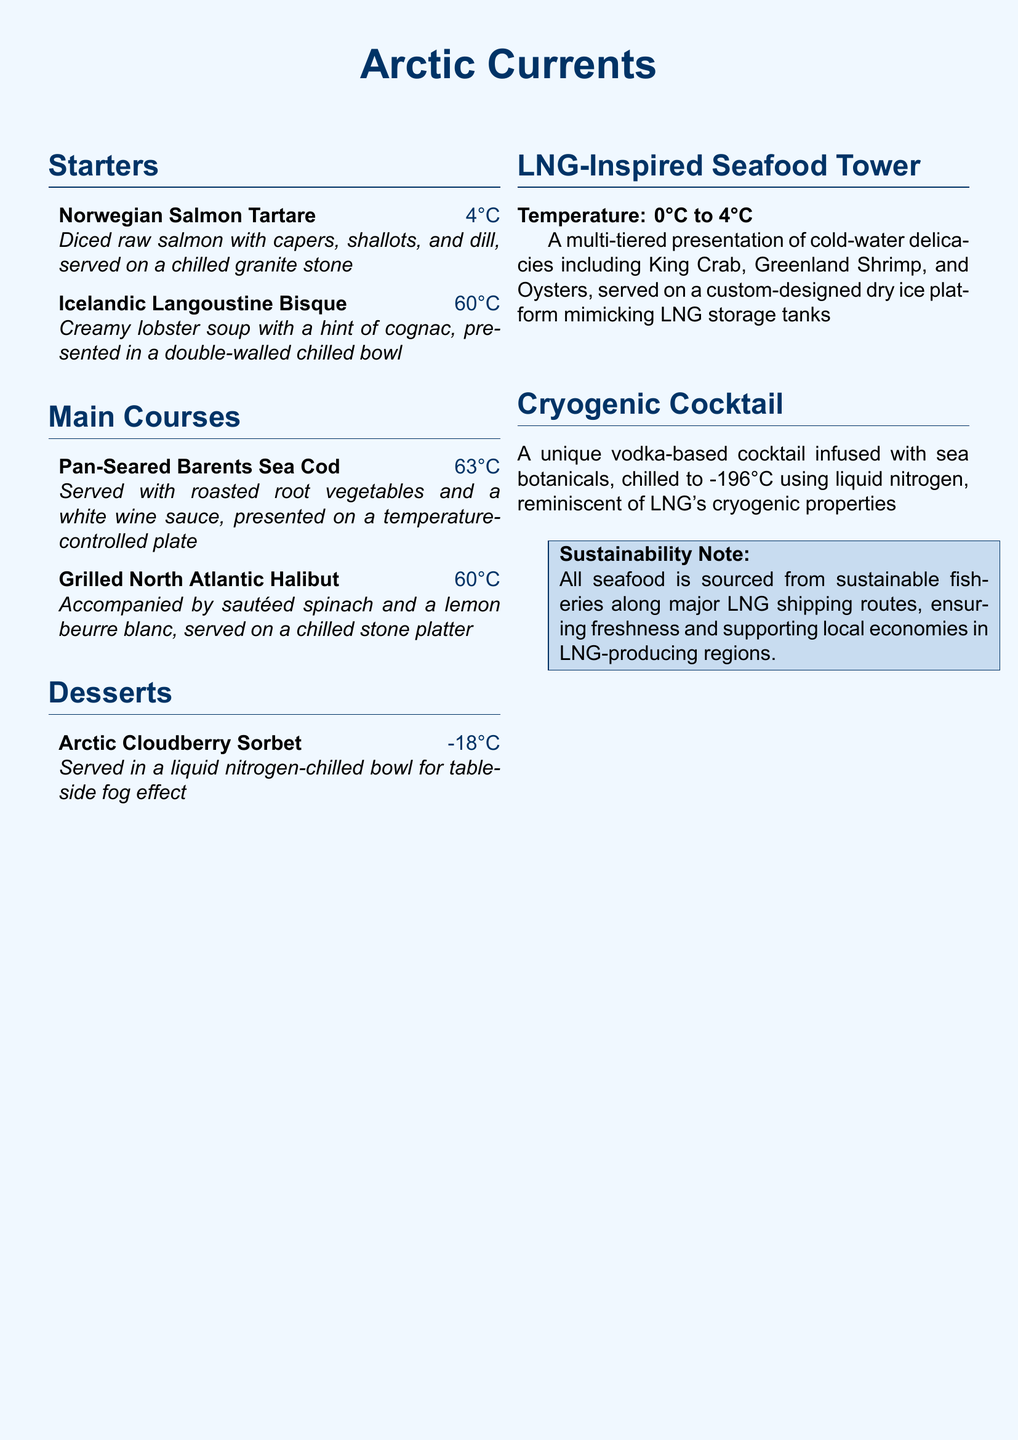What is the name of the seafood tower? The seafood tower is called the "LNG-Inspired Seafood Tower," as mentioned in the menu section.
Answer: LNG-Inspired Seafood Tower At what temperature is the Arctic Cloudberry Sorbet served? The temperature for serving the sorbet is given in the menu as -18°C.
Answer: -18°C What type of cocktail is offered in the menu? The cocktail is described as a unique vodka-based cocktail infused with sea botanicals.
Answer: Vodka-based cocktail Which cold-water fish is accompanied by lemon beurre blanc? The menu mentions that the North Atlantic Halibut is accompanied by lemon beurre blanc.
Answer: North Atlantic Halibut What is the serving temperature of the Pan-Seared Barents Sea Cod? The specified serving temperature for the cod is 63°C, as indicated in the menu.
Answer: 63°C Which ingredient is used in the Icelandic Langoustine Bisque? The bisque is creamy and contains a hint of cognac, as stated in the description.
Answer: Cognac What note is included about sustainability in the menu? The sustainability note mentions that all seafood is sourced from sustainable fisheries along major LNG shipping routes.
Answer: Sustainable fisheries What type of bowl is used for the Icelandic Langoustine Bisque? The bisque is presented in a double-walled chilled bowl according to the menu.
Answer: Double-walled chilled bowl 